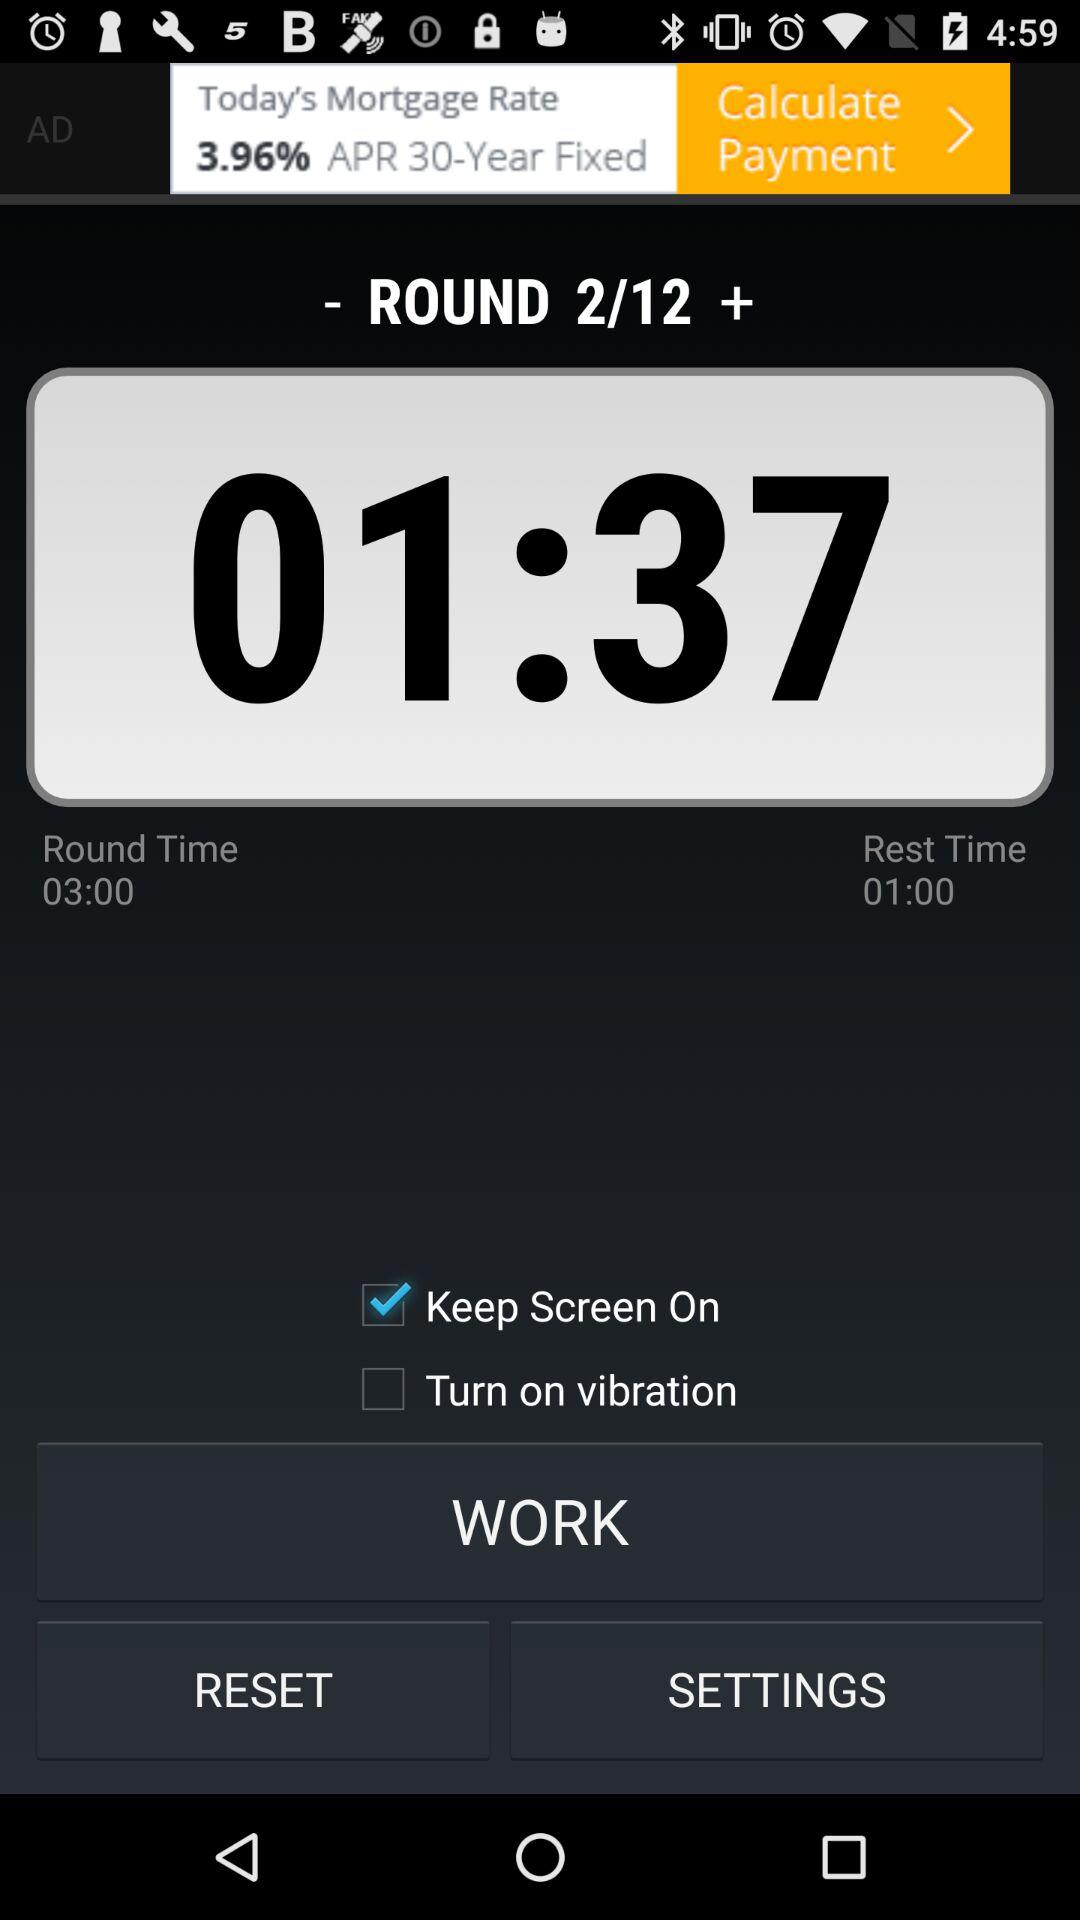What is the total number of rounds? The total number of rounds is 12. 